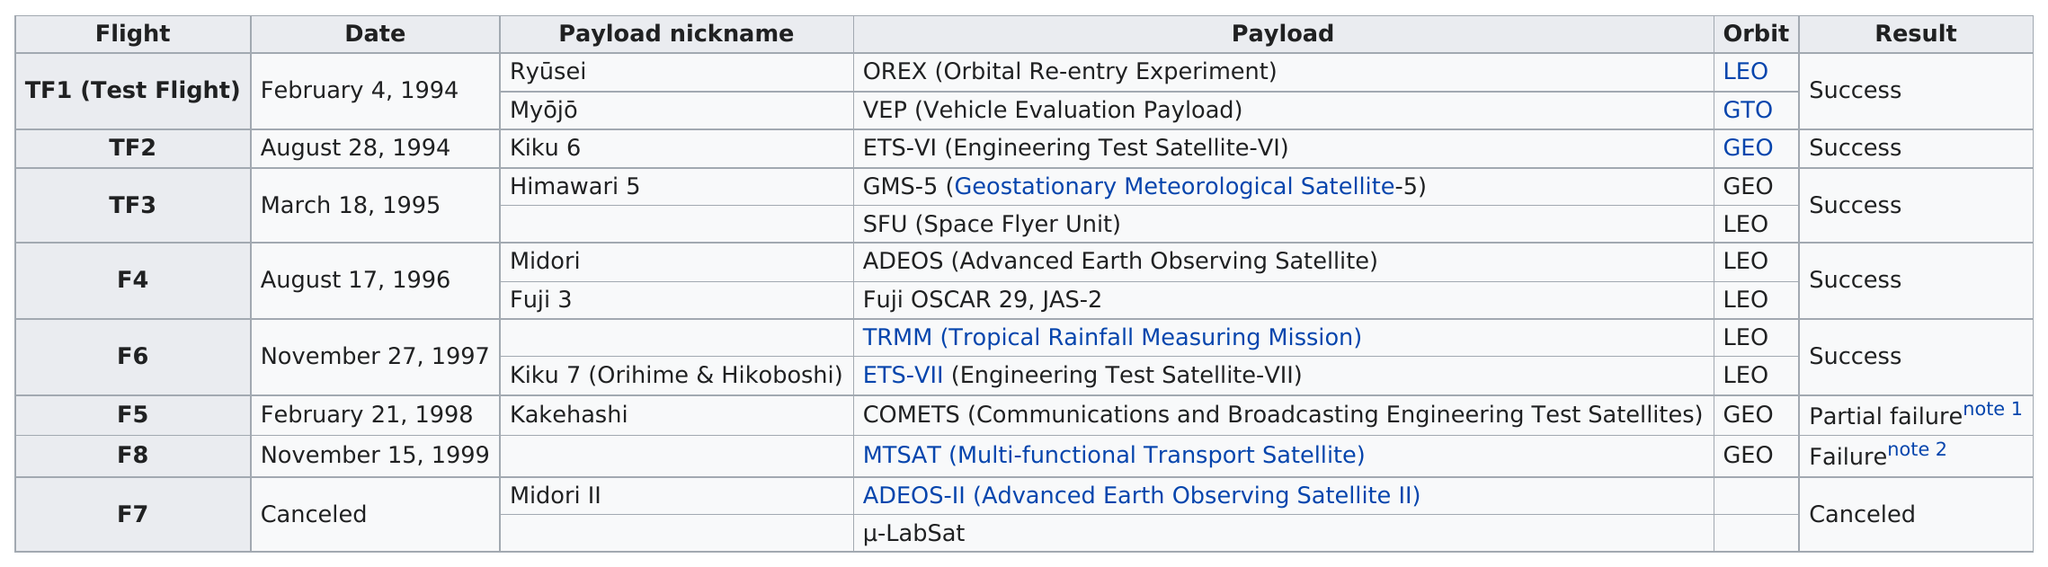Mention a couple of crucial points in this snapshot. According to the chart, the number of most flights that were canceled was one. On February 21, 1998, it had been approximately 3 years and 108 days since the orbit last reached the geostationary orbit since March 18, 1995. There were a total of 1 partial failure of h-ii flights. The last successful H-II flight occurred on November 27, 1997. The flight F7 was the only one that was cancelled. 